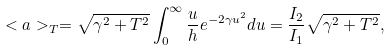Convert formula to latex. <formula><loc_0><loc_0><loc_500><loc_500>< a > _ { T } = \sqrt { \gamma ^ { 2 } + T ^ { 2 } } \int _ { 0 } ^ { \infty } \frac { u } { h } e ^ { - 2 \gamma u ^ { 2 } } d u = \frac { I _ { 2 } } { I _ { 1 } } \sqrt { \gamma ^ { 2 } + T ^ { 2 } } ,</formula> 